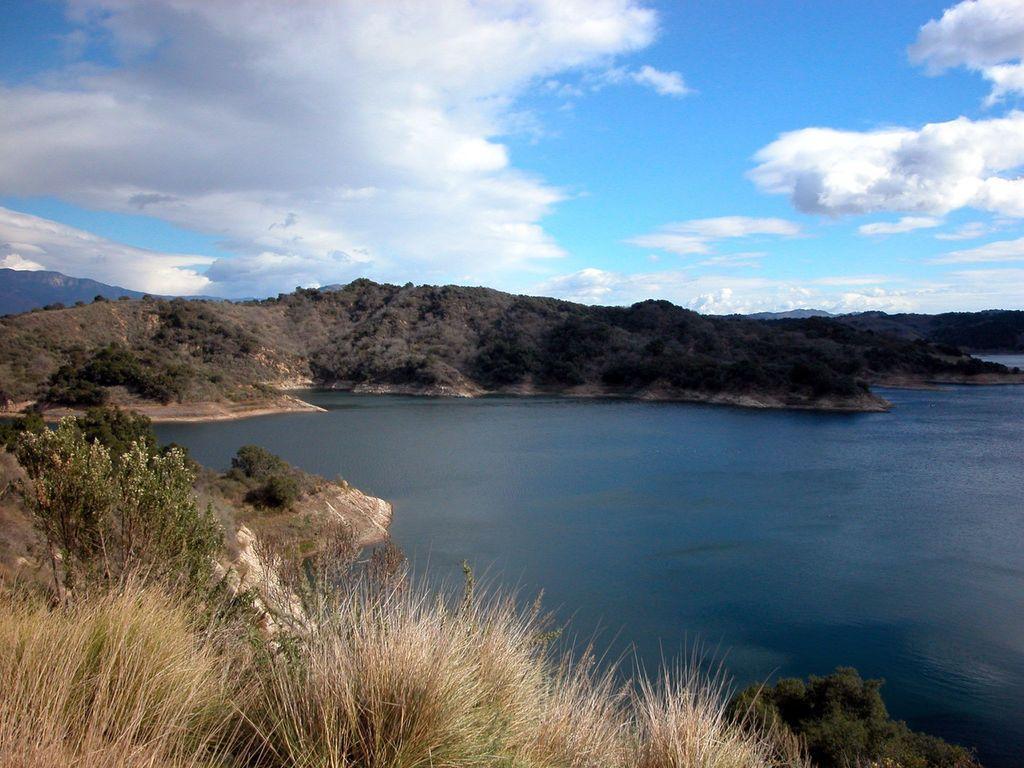In one or two sentences, can you explain what this image depicts? In the image there is a lake in the front with trees in front of it the hills and above its sky with clouds. 